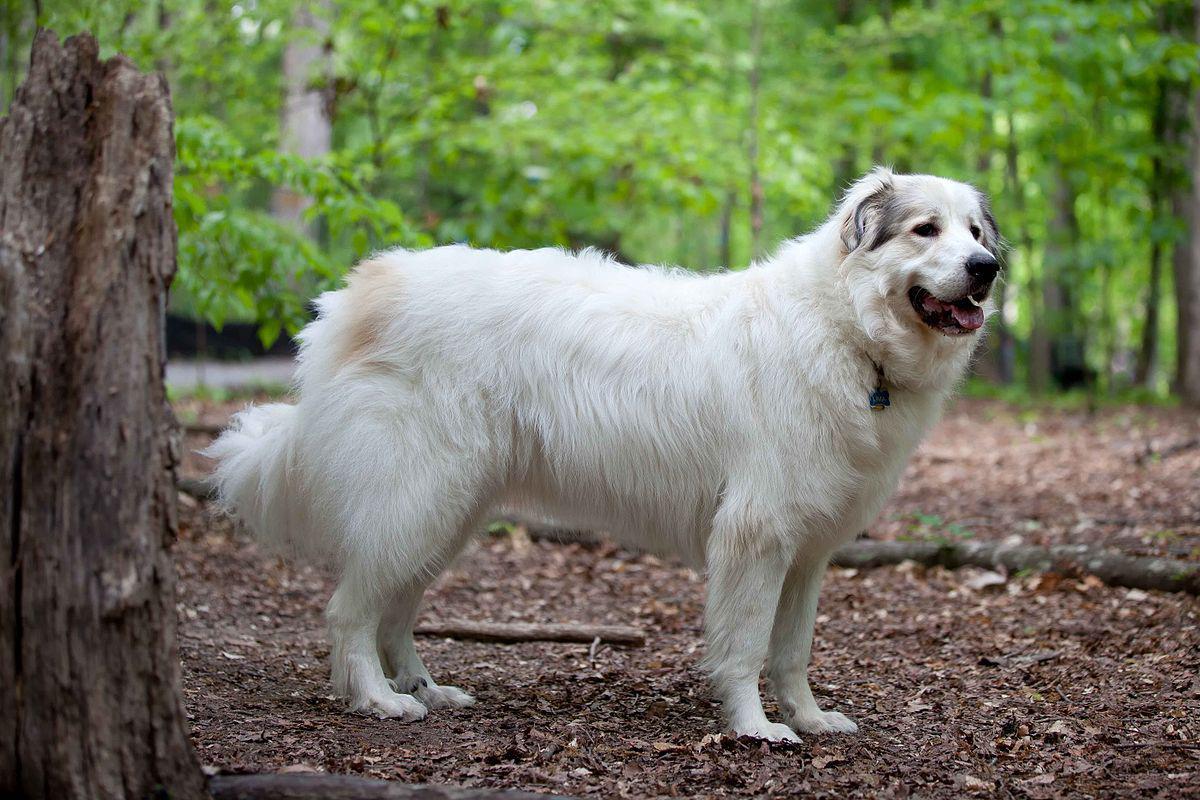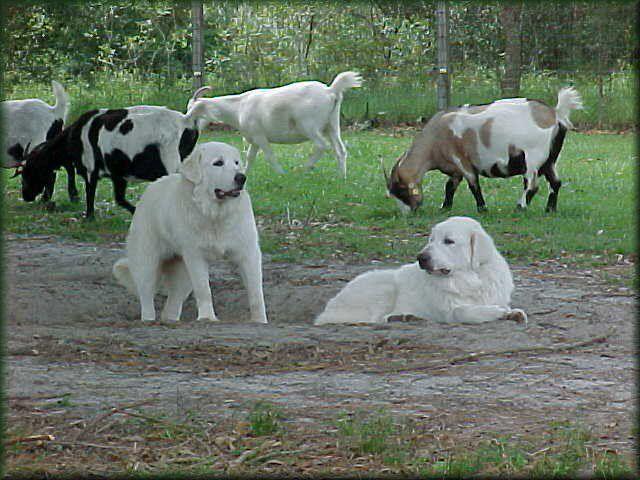The first image is the image on the left, the second image is the image on the right. Analyze the images presented: Is the assertion "There is exactly one dog and one goat in the image on the left." valid? Answer yes or no. No. 